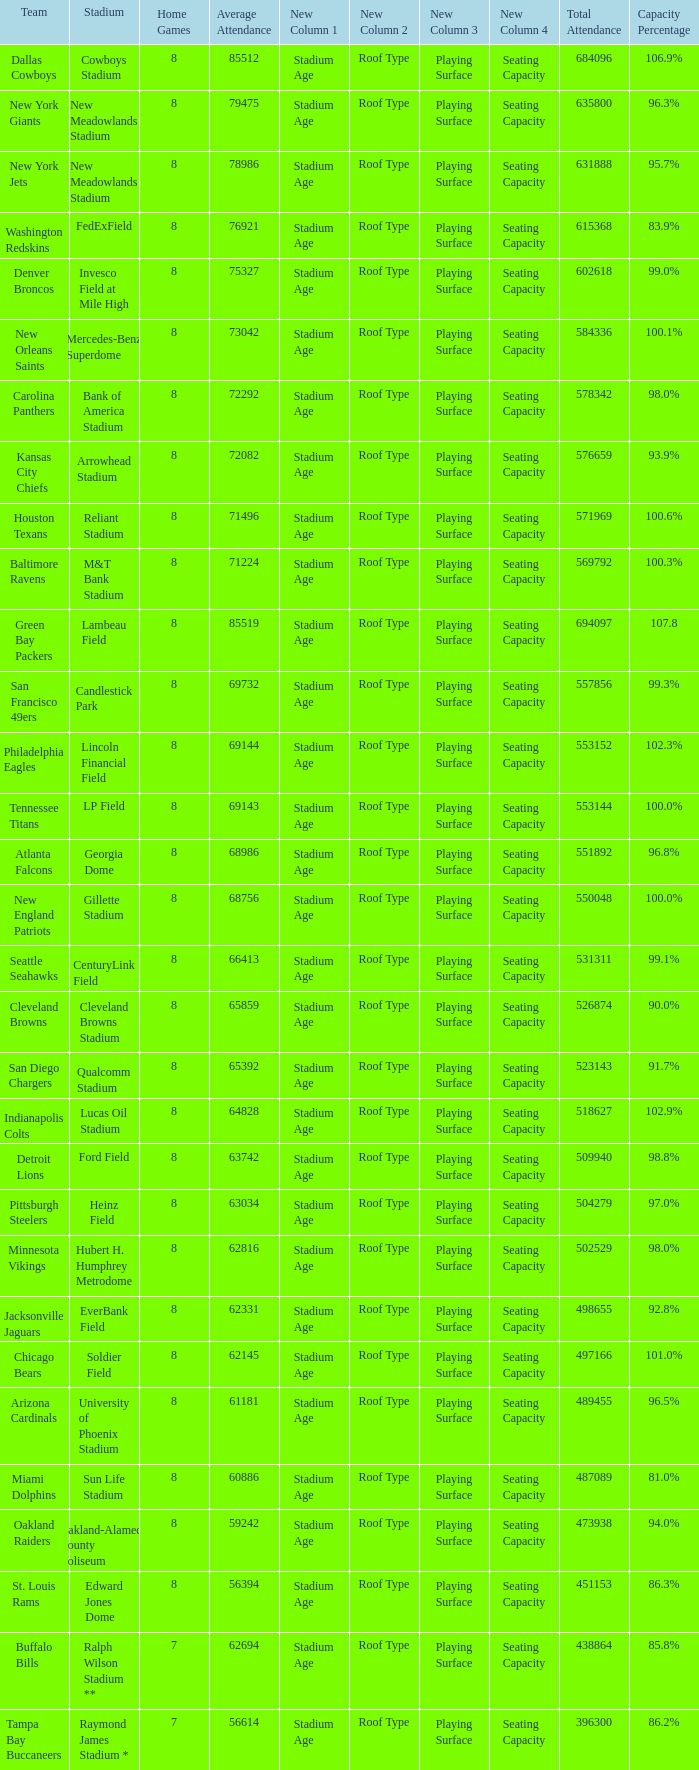What is the name of the stadium when the capacity percentage is 83.9% FedExField. 